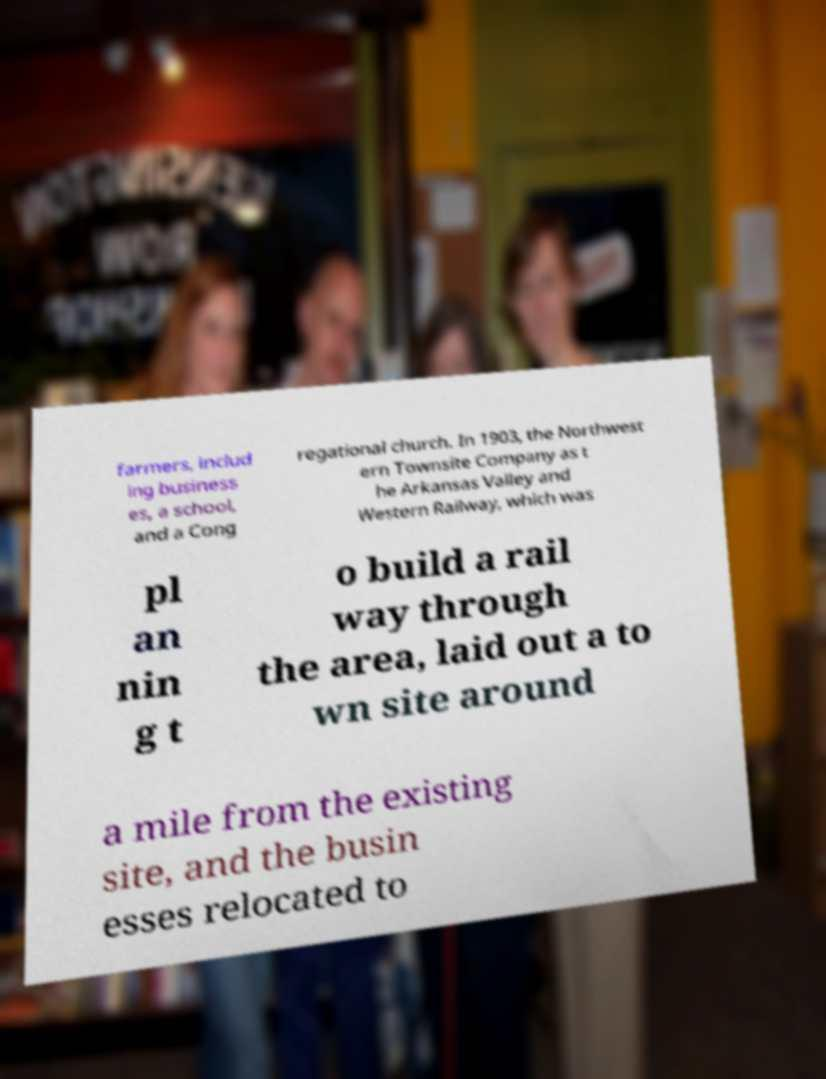Could you extract and type out the text from this image? farmers, includ ing business es, a school, and a Cong regational church. In 1903, the Northwest ern Townsite Company as t he Arkansas Valley and Western Railway, which was pl an nin g t o build a rail way through the area, laid out a to wn site around a mile from the existing site, and the busin esses relocated to 